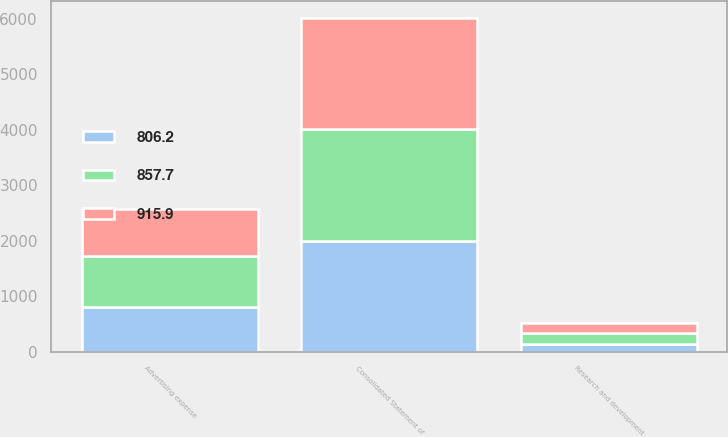<chart> <loc_0><loc_0><loc_500><loc_500><stacked_bar_chart><ecel><fcel>Consolidated Statement of<fcel>Research and development<fcel>Advertising expense<nl><fcel>857.7<fcel>2006<fcel>190.6<fcel>915.9<nl><fcel>915.9<fcel>2005<fcel>181<fcel>857.7<nl><fcel>806.2<fcel>2004<fcel>148.9<fcel>806.2<nl></chart> 